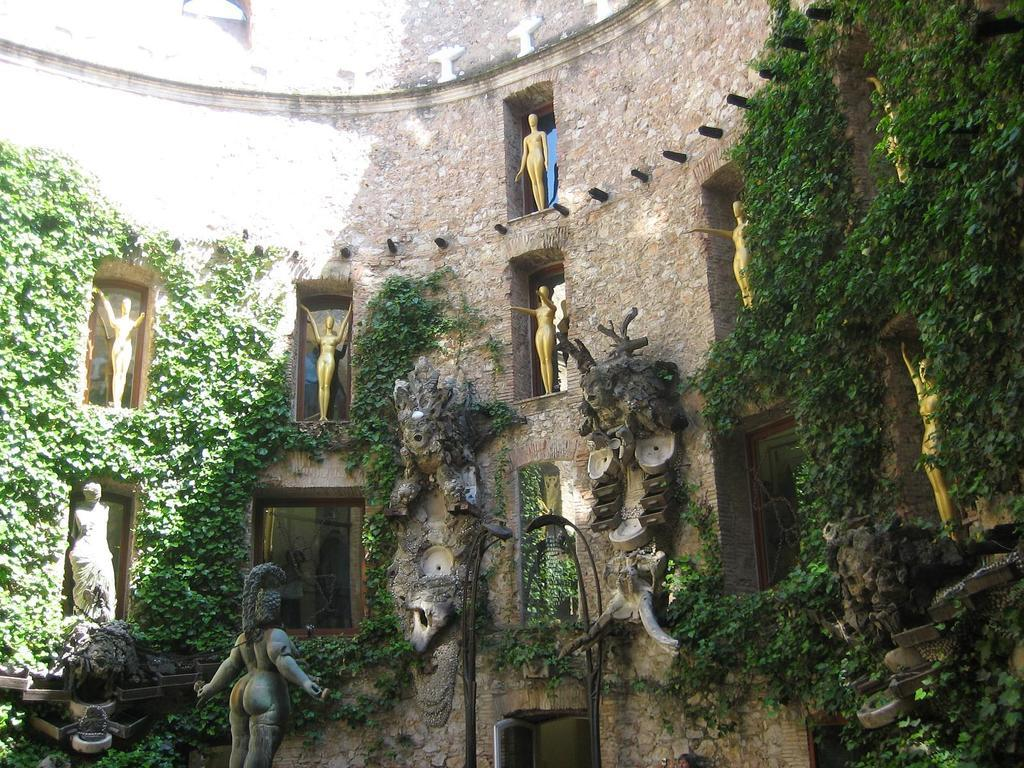What can be seen on the windows of the building in the image? There are statues on the windows of the building. What is present on the walls in the image? There are leaves on the walls. Can you see any steam coming from the leaves on the walls in the image? There is no steam present in the image; it features statues on the windows and leaves on the walls. Is there any verse written on the statues in the image? There is no verse present on the statues in the image; the statues are simply on the windows. 